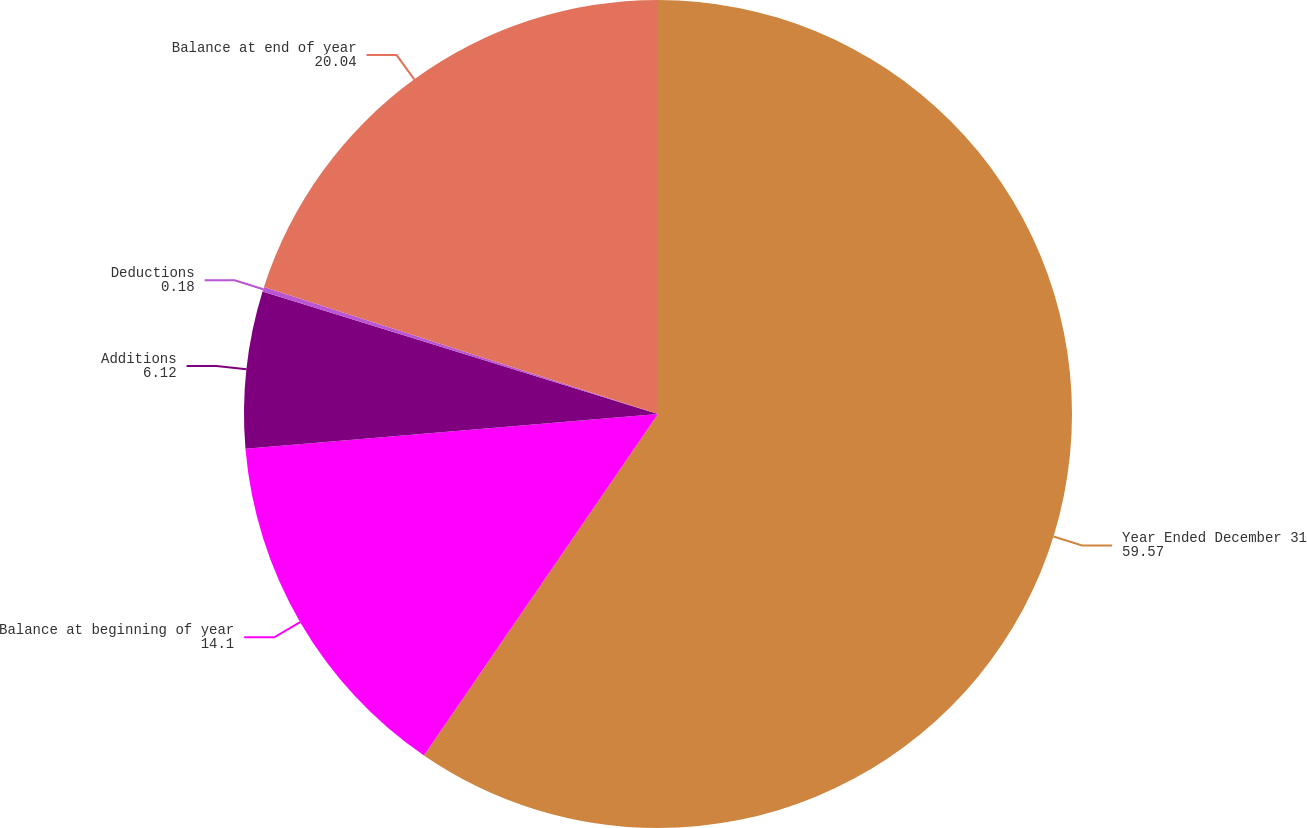Convert chart to OTSL. <chart><loc_0><loc_0><loc_500><loc_500><pie_chart><fcel>Year Ended December 31<fcel>Balance at beginning of year<fcel>Additions<fcel>Deductions<fcel>Balance at end of year<nl><fcel>59.57%<fcel>14.1%<fcel>6.12%<fcel>0.18%<fcel>20.04%<nl></chart> 